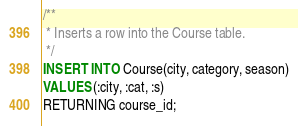Convert code to text. <code><loc_0><loc_0><loc_500><loc_500><_SQL_>/**
 * Inserts a row into the Course table.
 */
INSERT INTO Course(city, category, season)
VALUES (:city, :cat, :s)
RETURNING course_id;
</code> 